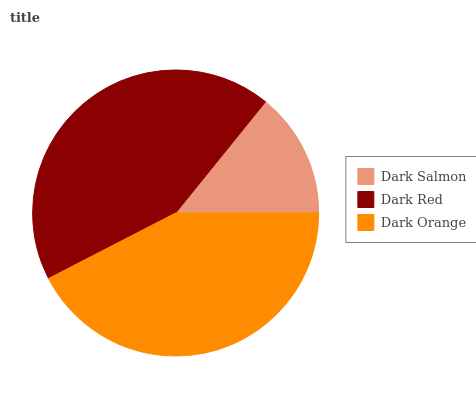Is Dark Salmon the minimum?
Answer yes or no. Yes. Is Dark Red the maximum?
Answer yes or no. Yes. Is Dark Orange the minimum?
Answer yes or no. No. Is Dark Orange the maximum?
Answer yes or no. No. Is Dark Red greater than Dark Orange?
Answer yes or no. Yes. Is Dark Orange less than Dark Red?
Answer yes or no. Yes. Is Dark Orange greater than Dark Red?
Answer yes or no. No. Is Dark Red less than Dark Orange?
Answer yes or no. No. Is Dark Orange the high median?
Answer yes or no. Yes. Is Dark Orange the low median?
Answer yes or no. Yes. Is Dark Red the high median?
Answer yes or no. No. Is Dark Red the low median?
Answer yes or no. No. 